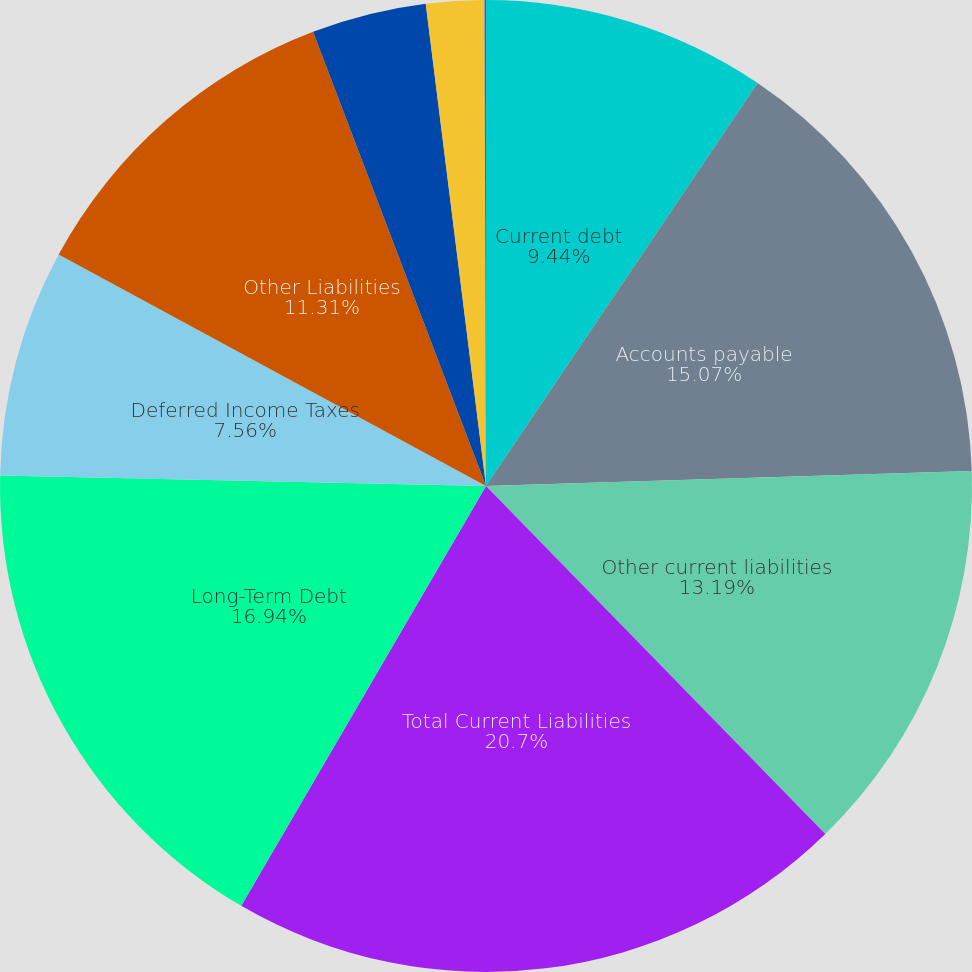Convert chart to OTSL. <chart><loc_0><loc_0><loc_500><loc_500><pie_chart><fcel>Current debt<fcel>Accounts payable<fcel>Other current liabilities<fcel>Total Current Liabilities<fcel>Long-Term Debt<fcel>Deferred Income Taxes<fcel>Other Liabilities<fcel>Redeemable Noncontrolling<fcel>Class A-authorized 900 million<fcel>Convertible Class B-authorized<nl><fcel>9.44%<fcel>15.07%<fcel>13.19%<fcel>20.7%<fcel>16.94%<fcel>7.56%<fcel>11.31%<fcel>3.81%<fcel>1.93%<fcel>0.05%<nl></chart> 